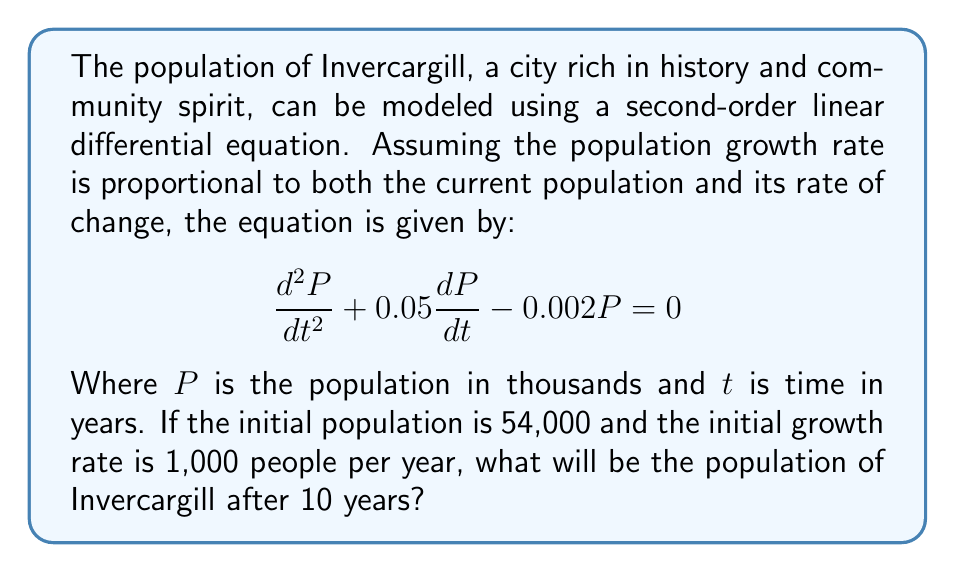Can you answer this question? To solve this problem, we need to follow these steps:

1) First, we need to find the general solution of the differential equation. The characteristic equation is:

   $$r^2 + 0.05r - 0.002 = 0$$

2) Solving this quadratic equation:
   $$r = \frac{-0.05 \pm \sqrt{0.05^2 + 4(0.002)}}{2} = \frac{-0.05 \pm \sqrt{0.0025 + 0.008}}{2} = \frac{-0.05 \pm \sqrt{0.0105}}{2}$$

   $$r_1 \approx 0.0520 \text{ and } r_2 \approx -0.1020$$

3) The general solution is thus:
   $$P(t) = C_1e^{0.0520t} + C_2e^{-0.1020t}$$

4) Now we use the initial conditions to find $C_1$ and $C_2$:
   
   At $t=0$, $P(0) = 54$, so:
   $$54 = C_1 + C_2$$

   Also, $P'(0) = 1$, so:
   $$1 = 0.0520C_1 - 0.1020C_2$$

5) Solving these simultaneous equations:
   $$C_1 \approx 61.9355 \text{ and } C_2 \approx -7.9355$$

6) Therefore, the particular solution is:
   $$P(t) = 61.9355e^{0.0520t} - 7.9355e^{-0.1020t}$$

7) To find the population after 10 years, we calculate $P(10)$:
   $$P(10) = 61.9355e^{0.5200} - 7.9355e^{-1.0200}$$
   $$= 61.9355(1.6821) - 7.9355(0.3606)$$
   $$= 104.1796 - 2.8615$$
   $$= 101.3181$$

8) Since $P$ is in thousands, we multiply by 1000 to get the actual population.
Answer: The population of Invercargill after 10 years will be approximately 101,318 people. 